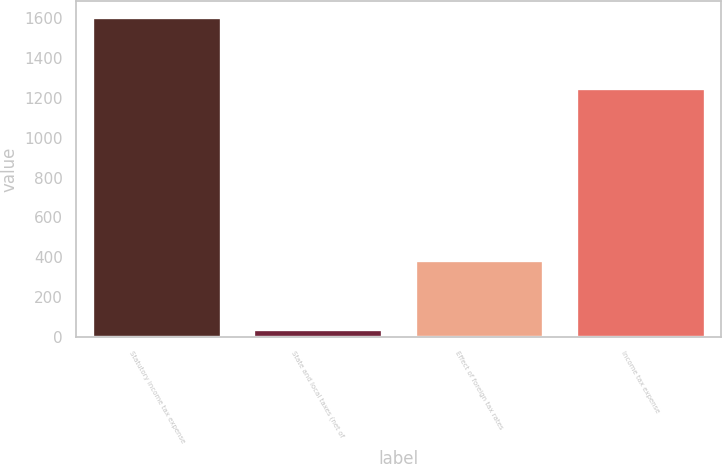<chart> <loc_0><loc_0><loc_500><loc_500><bar_chart><fcel>Statutory income tax expense<fcel>State and local taxes (net of<fcel>Effect of foreign tax rates<fcel>Income tax expense<nl><fcel>1608<fcel>42<fcel>385<fcel>1250<nl></chart> 